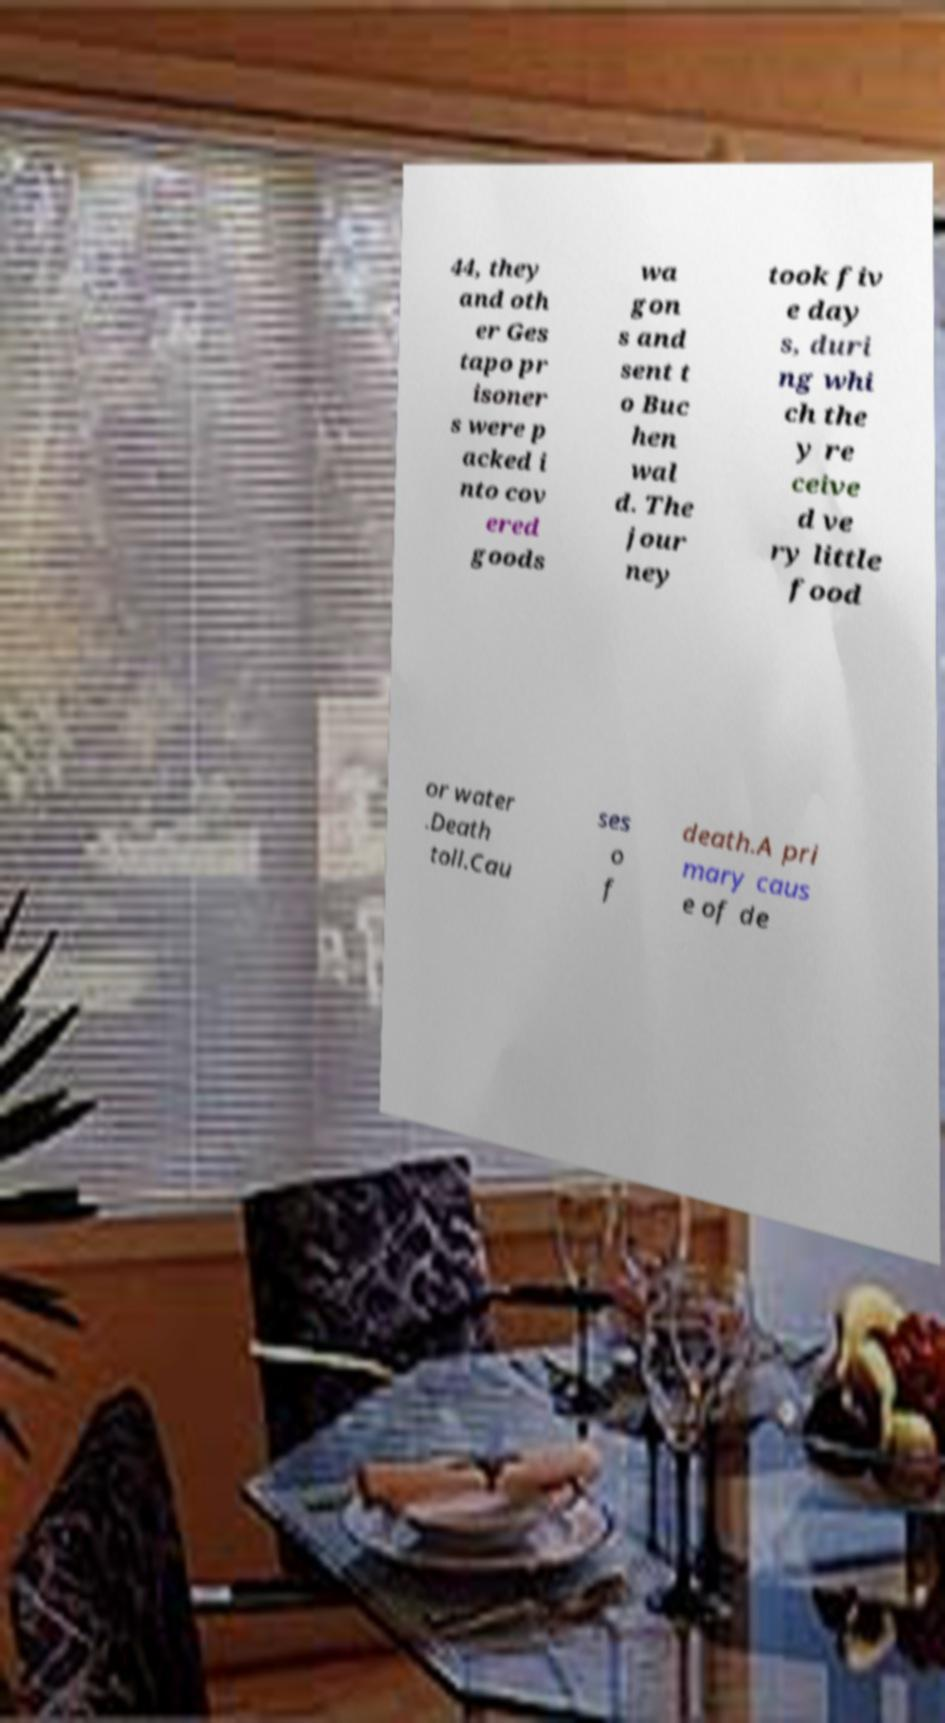I need the written content from this picture converted into text. Can you do that? 44, they and oth er Ges tapo pr isoner s were p acked i nto cov ered goods wa gon s and sent t o Buc hen wal d. The jour ney took fiv e day s, duri ng whi ch the y re ceive d ve ry little food or water .Death toll.Cau ses o f death.A pri mary caus e of de 